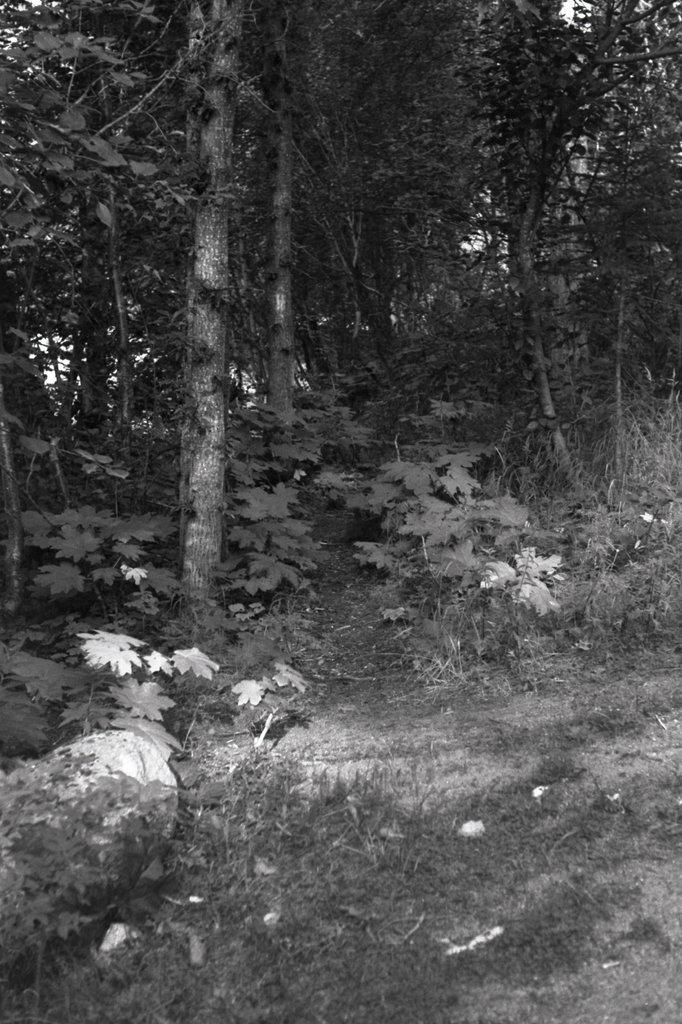What is the color scheme of the image? The image is black and white. What type of vegetation can be seen in the image? There is grass, plants, and trees in the image. What part of the natural environment is visible in the image? The sky is visible in the image. Are there any cacti visible in the image? There is no mention of cacti in the provided facts, so we cannot determine if any are present in the image. 